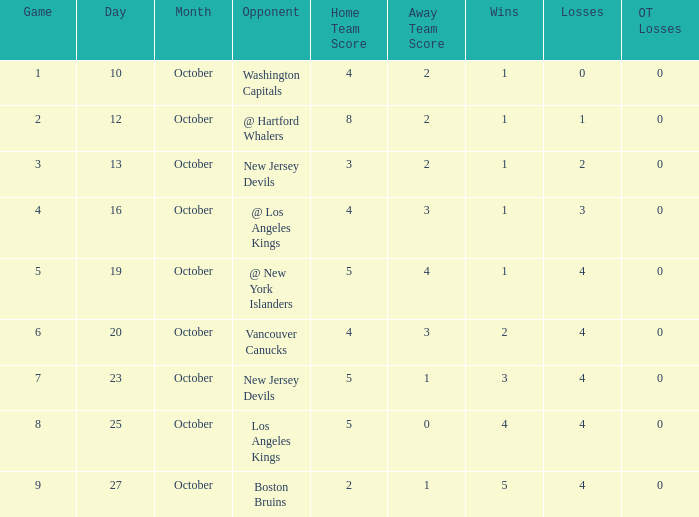What was the average game with a record of 4-4-0? 8.0. 